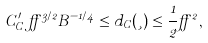Convert formula to latex. <formula><loc_0><loc_0><loc_500><loc_500>C _ { C } ^ { \prime } \, \alpha ^ { 3 / 2 } B ^ { - 1 / 4 } \leq d _ { C } ( \xi ) \leq \frac { 1 } { 2 } \alpha ^ { 2 } ,</formula> 